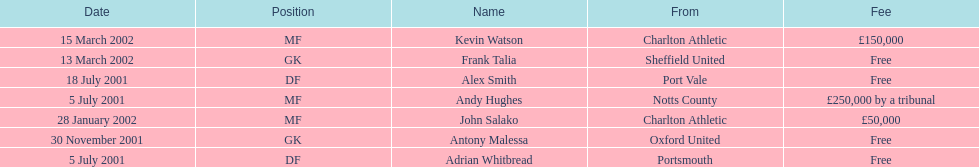Could you parse the entire table as a dict? {'header': ['Date', 'Position', 'Name', 'From', 'Fee'], 'rows': [['15 March 2002', 'MF', 'Kevin Watson', 'Charlton Athletic', '£150,000'], ['13 March 2002', 'GK', 'Frank Talia', 'Sheffield United', 'Free'], ['18 July 2001', 'DF', 'Alex Smith', 'Port Vale', 'Free'], ['5 July 2001', 'MF', 'Andy Hughes', 'Notts County', '£250,000 by a tribunal'], ['28 January 2002', 'MF', 'John Salako', 'Charlton Athletic', '£50,000'], ['30 November 2001', 'GK', 'Antony Malessa', 'Oxford United', 'Free'], ['5 July 2001', 'DF', 'Adrian Whitbread', 'Portsmouth', 'Free']]} Who transferred after 30 november 2001? John Salako, Frank Talia, Kevin Watson. 